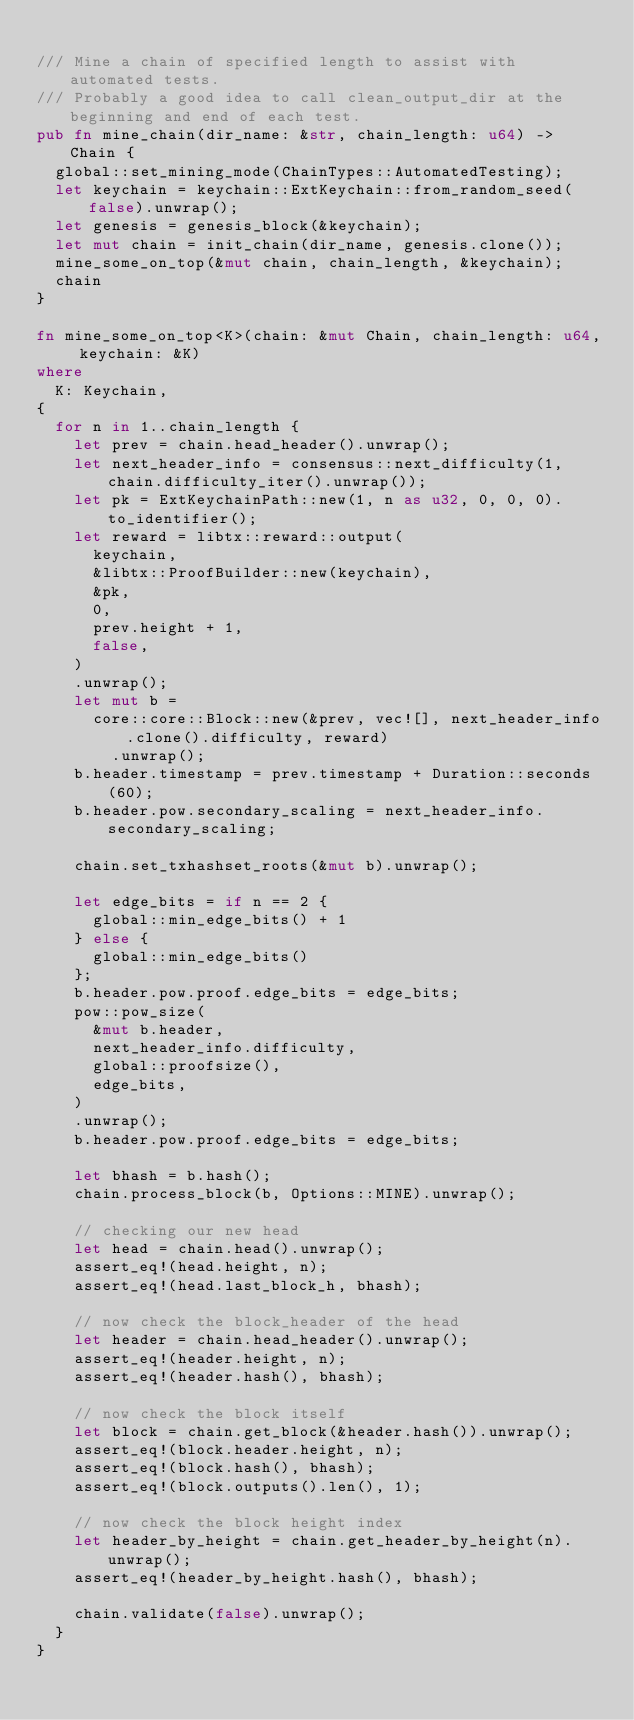<code> <loc_0><loc_0><loc_500><loc_500><_Rust_>
/// Mine a chain of specified length to assist with automated tests.
/// Probably a good idea to call clean_output_dir at the beginning and end of each test.
pub fn mine_chain(dir_name: &str, chain_length: u64) -> Chain {
	global::set_mining_mode(ChainTypes::AutomatedTesting);
	let keychain = keychain::ExtKeychain::from_random_seed(false).unwrap();
	let genesis = genesis_block(&keychain);
	let mut chain = init_chain(dir_name, genesis.clone());
	mine_some_on_top(&mut chain, chain_length, &keychain);
	chain
}

fn mine_some_on_top<K>(chain: &mut Chain, chain_length: u64, keychain: &K)
where
	K: Keychain,
{
	for n in 1..chain_length {
		let prev = chain.head_header().unwrap();
		let next_header_info = consensus::next_difficulty(1, chain.difficulty_iter().unwrap());
		let pk = ExtKeychainPath::new(1, n as u32, 0, 0, 0).to_identifier();
		let reward = libtx::reward::output(
			keychain,
			&libtx::ProofBuilder::new(keychain),
			&pk,
			0,
			prev.height + 1,
			false,
		)
		.unwrap();
		let mut b =
			core::core::Block::new(&prev, vec![], next_header_info.clone().difficulty, reward)
				.unwrap();
		b.header.timestamp = prev.timestamp + Duration::seconds(60);
		b.header.pow.secondary_scaling = next_header_info.secondary_scaling;

		chain.set_txhashset_roots(&mut b).unwrap();

		let edge_bits = if n == 2 {
			global::min_edge_bits() + 1
		} else {
			global::min_edge_bits()
		};
		b.header.pow.proof.edge_bits = edge_bits;
		pow::pow_size(
			&mut b.header,
			next_header_info.difficulty,
			global::proofsize(),
			edge_bits,
		)
		.unwrap();
		b.header.pow.proof.edge_bits = edge_bits;

		let bhash = b.hash();
		chain.process_block(b, Options::MINE).unwrap();

		// checking our new head
		let head = chain.head().unwrap();
		assert_eq!(head.height, n);
		assert_eq!(head.last_block_h, bhash);

		// now check the block_header of the head
		let header = chain.head_header().unwrap();
		assert_eq!(header.height, n);
		assert_eq!(header.hash(), bhash);

		// now check the block itself
		let block = chain.get_block(&header.hash()).unwrap();
		assert_eq!(block.header.height, n);
		assert_eq!(block.hash(), bhash);
		assert_eq!(block.outputs().len(), 1);

		// now check the block height index
		let header_by_height = chain.get_header_by_height(n).unwrap();
		assert_eq!(header_by_height.hash(), bhash);

		chain.validate(false).unwrap();
	}
}
</code> 